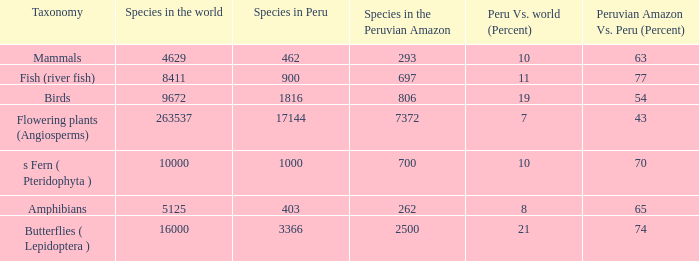What's the maximum peru vs. world (percent) with 9672 species in the world  19.0. 